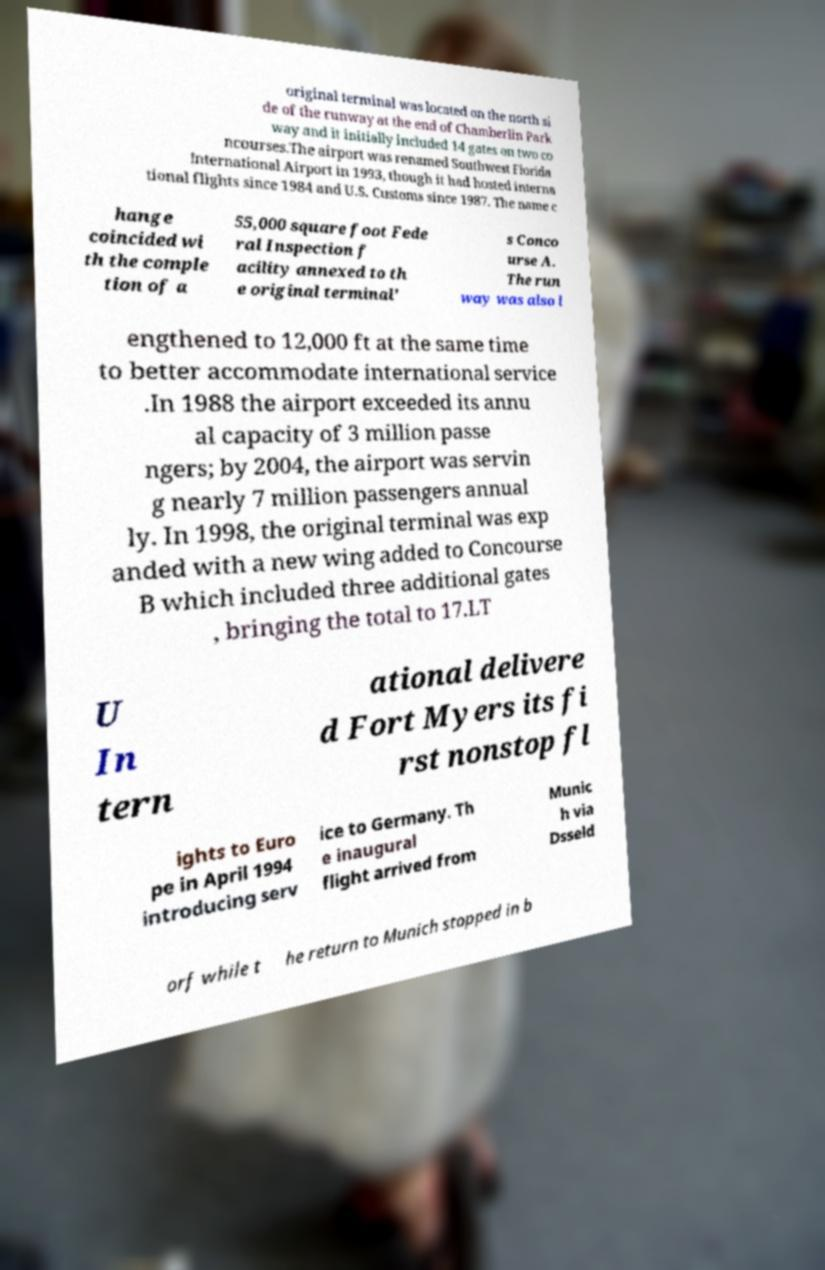Please read and relay the text visible in this image. What does it say? original terminal was located on the north si de of the runway at the end of Chamberlin Park way and it initially included 14 gates on two co ncourses.The airport was renamed Southwest Florida International Airport in 1993, though it had hosted interna tional flights since 1984 and U.S. Customs since 1987. The name c hange coincided wi th the comple tion of a 55,000 square foot Fede ral Inspection f acility annexed to th e original terminal' s Conco urse A. The run way was also l engthened to 12,000 ft at the same time to better accommodate international service .In 1988 the airport exceeded its annu al capacity of 3 million passe ngers; by 2004, the airport was servin g nearly 7 million passengers annual ly. In 1998, the original terminal was exp anded with a new wing added to Concourse B which included three additional gates , bringing the total to 17.LT U In tern ational delivere d Fort Myers its fi rst nonstop fl ights to Euro pe in April 1994 introducing serv ice to Germany. Th e inaugural flight arrived from Munic h via Dsseld orf while t he return to Munich stopped in b 